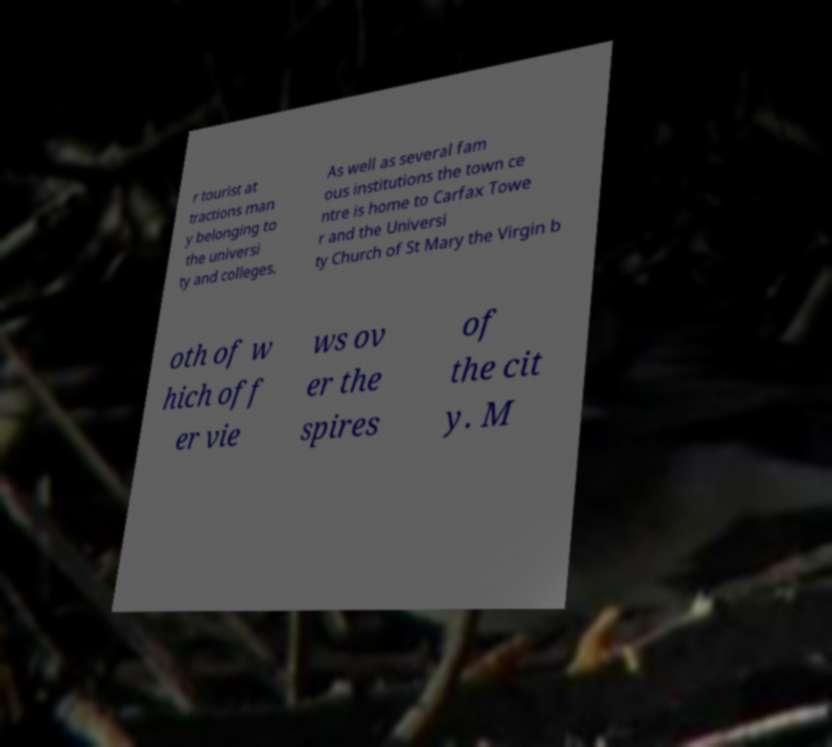Could you extract and type out the text from this image? r tourist at tractions man y belonging to the universi ty and colleges. As well as several fam ous institutions the town ce ntre is home to Carfax Towe r and the Universi ty Church of St Mary the Virgin b oth of w hich off er vie ws ov er the spires of the cit y. M 